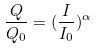<formula> <loc_0><loc_0><loc_500><loc_500>\frac { Q } { Q _ { 0 } } = ( \frac { I } { I _ { 0 } } ) ^ { \alpha }</formula> 